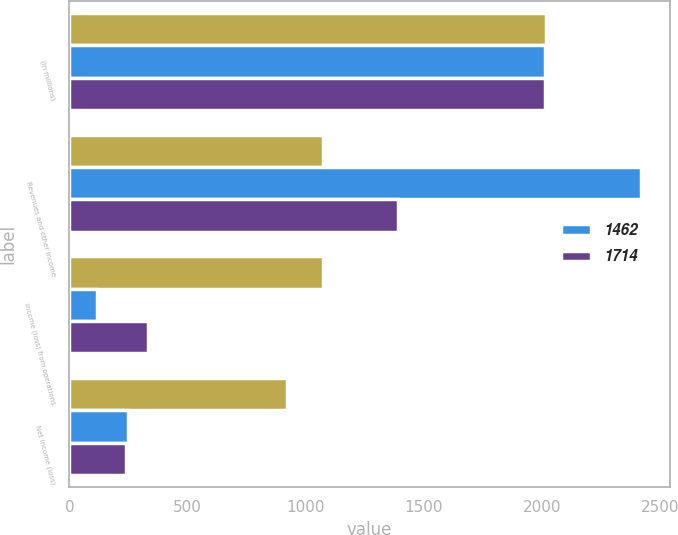Convert chart. <chart><loc_0><loc_0><loc_500><loc_500><stacked_bar_chart><ecel><fcel>(In millions)<fcel>Revenues and other income<fcel>Income (loss) from operations<fcel>Net income (loss)<nl><fcel>nan<fcel>2017<fcel>1075<fcel>1075<fcel>922<nl><fcel>1462<fcel>2016<fcel>2421<fcel>116<fcel>250<nl><fcel>1714<fcel>2015<fcel>1390<fcel>332<fcel>239<nl></chart> 